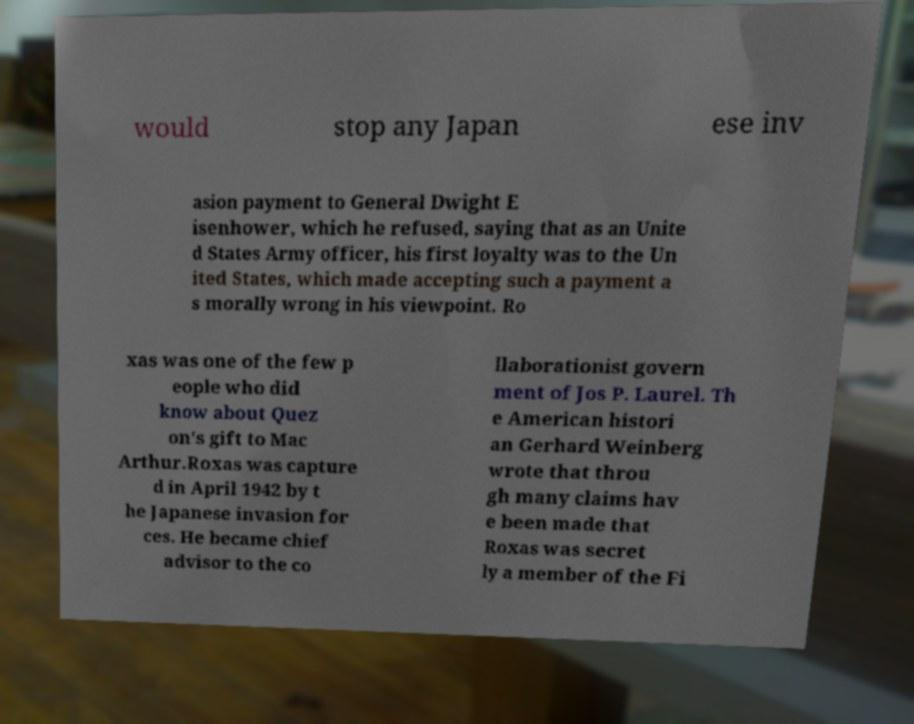Can you accurately transcribe the text from the provided image for me? would stop any Japan ese inv asion payment to General Dwight E isenhower, which he refused, saying that as an Unite d States Army officer, his first loyalty was to the Un ited States, which made accepting such a payment a s morally wrong in his viewpoint. Ro xas was one of the few p eople who did know about Quez on's gift to Mac Arthur.Roxas was capture d in April 1942 by t he Japanese invasion for ces. He became chief advisor to the co llaborationist govern ment of Jos P. Laurel. Th e American histori an Gerhard Weinberg wrote that throu gh many claims hav e been made that Roxas was secret ly a member of the Fi 